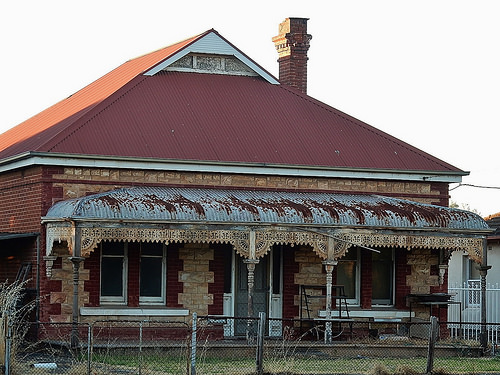<image>
Is there a fence behind the plant? Yes. From this viewpoint, the fence is positioned behind the plant, with the plant partially or fully occluding the fence. 